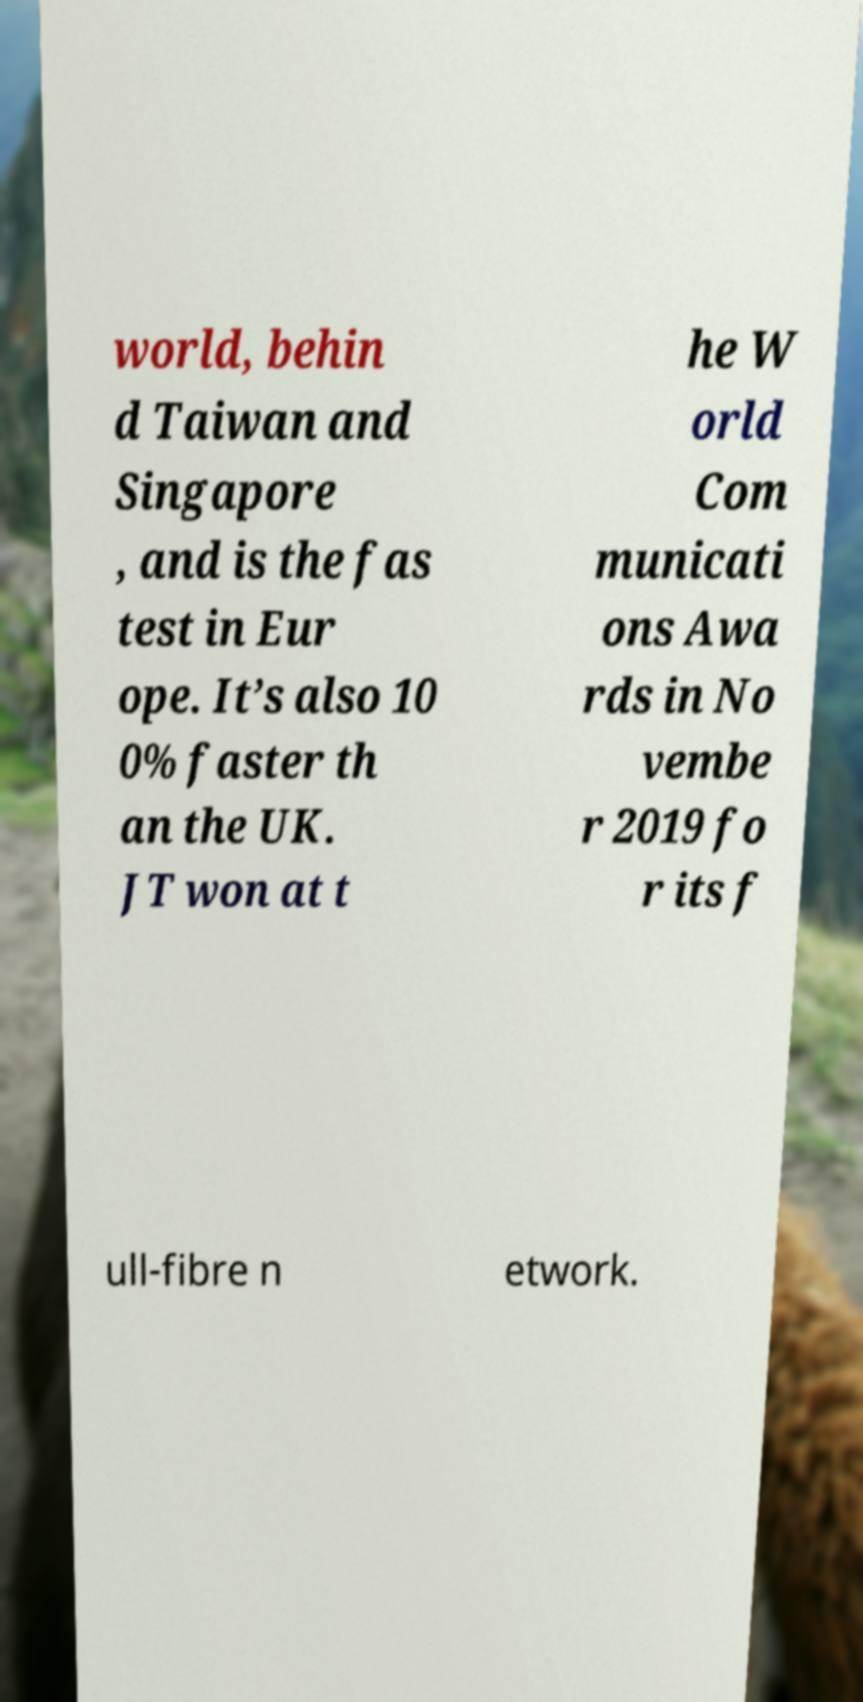Please read and relay the text visible in this image. What does it say? world, behin d Taiwan and Singapore , and is the fas test in Eur ope. It’s also 10 0% faster th an the UK. JT won at t he W orld Com municati ons Awa rds in No vembe r 2019 fo r its f ull-fibre n etwork. 